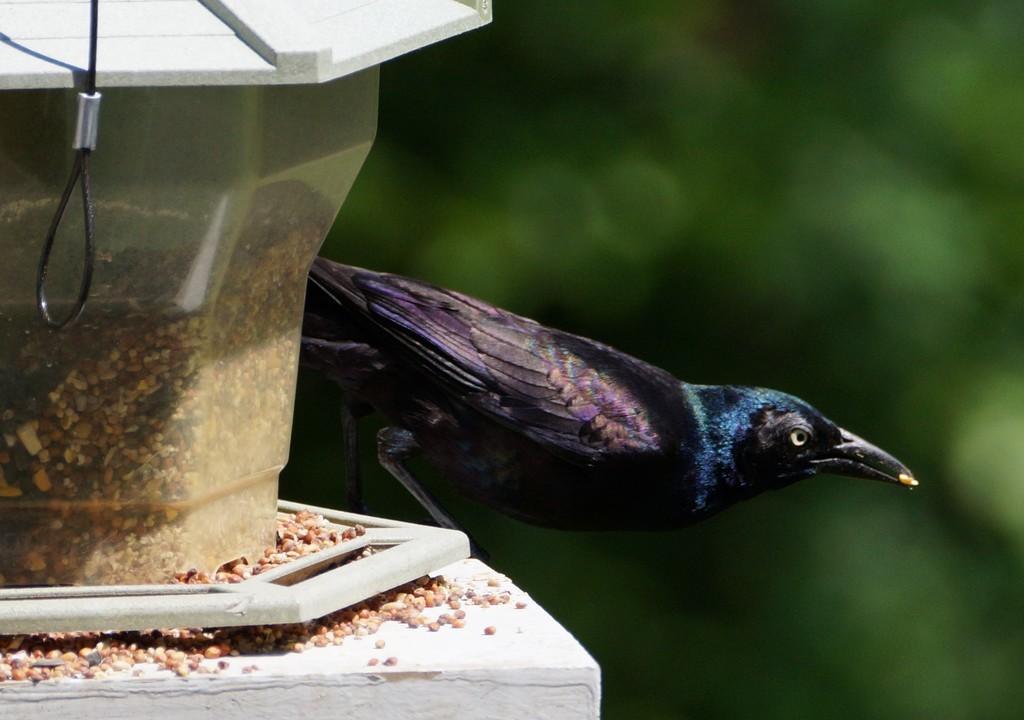Could you give a brief overview of what you see in this image? In the foreground of this image, there is a bird on the bird feeding station and the background image is blur. 